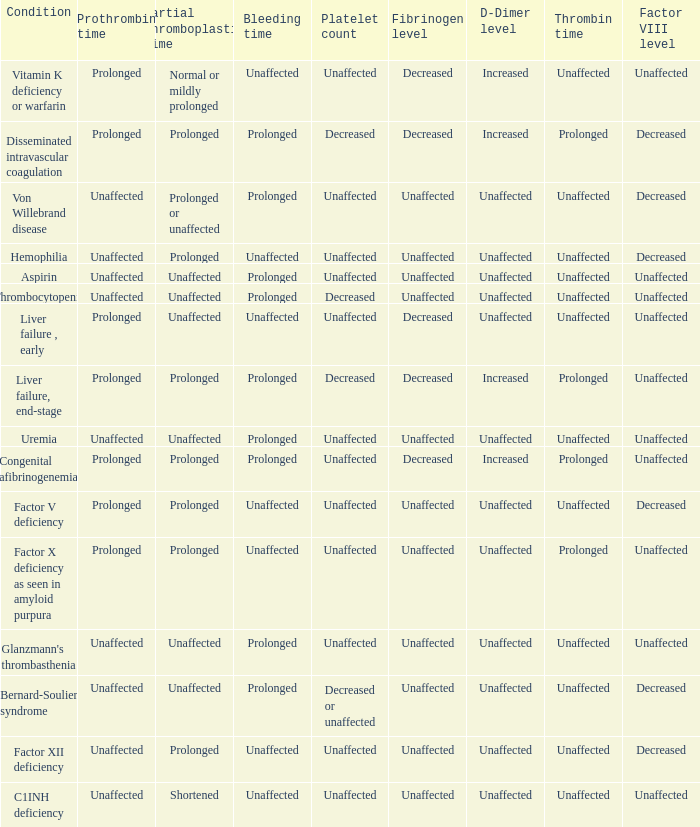Which Condition has an unaffected Partial thromboplastin time, Platelet count, and a Prothrombin time? Aspirin, Uremia, Glanzmann's thrombasthenia. 